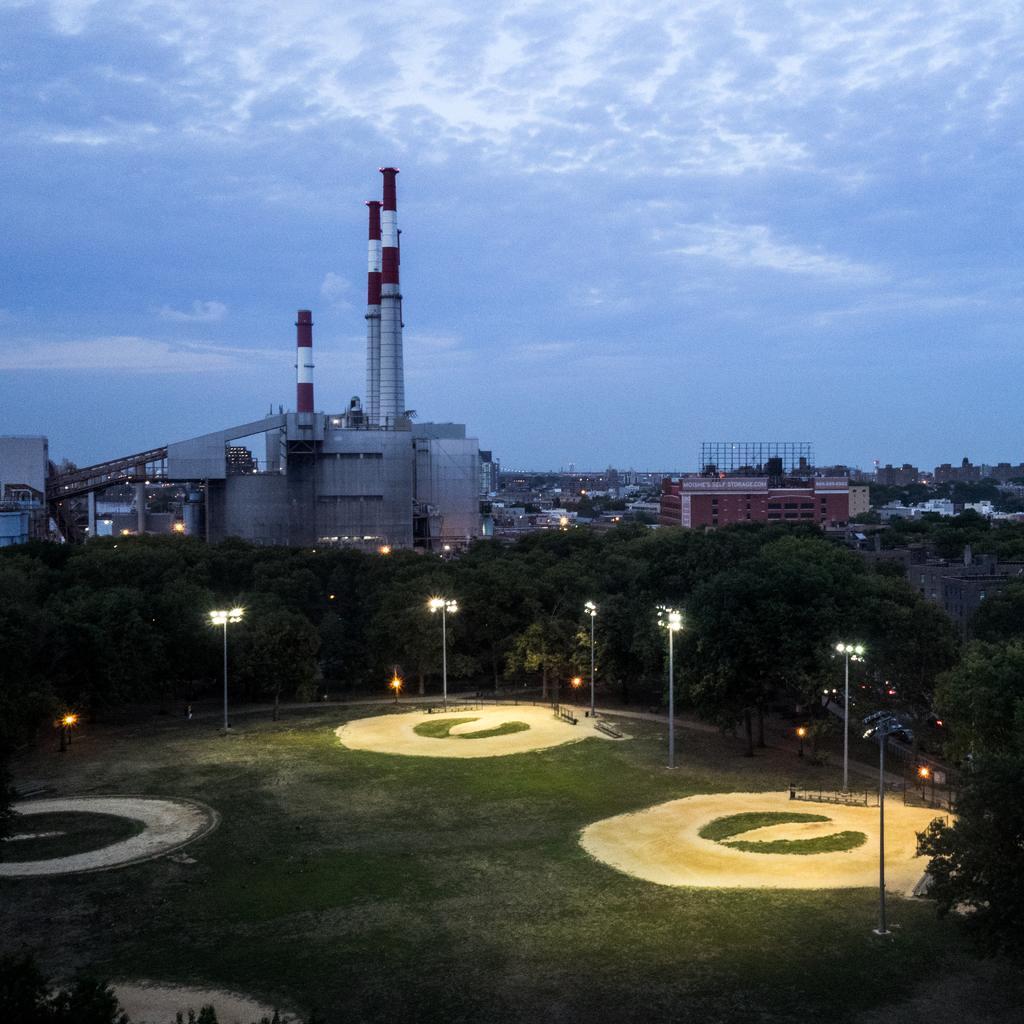In one or two sentences, can you explain what this image depicts? In this picture on the right side, we can see some trees, buildings. On the left side, we can also see some trees, buildings. In the background, we can see some street lights, machines and buildings. On the top, we can see a sky, at the bottom there is a grass. 